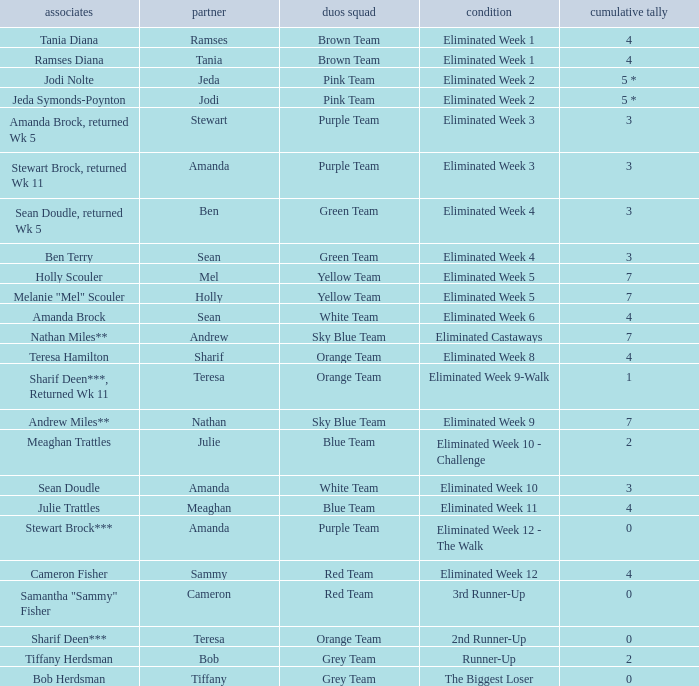What were Holly Scouler's total votes? 7.0. 